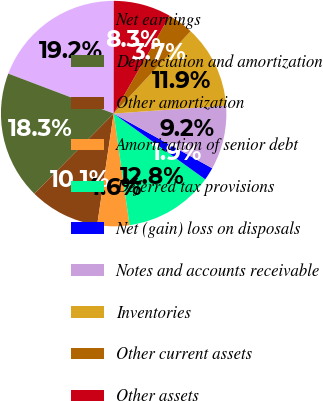Convert chart to OTSL. <chart><loc_0><loc_0><loc_500><loc_500><pie_chart><fcel>Net earnings<fcel>Depreciation and amortization<fcel>Other amortization<fcel>Amortization of senior debt<fcel>Deferred tax provisions<fcel>Net (gain) loss on disposals<fcel>Notes and accounts receivable<fcel>Inventories<fcel>Other current assets<fcel>Other assets<nl><fcel>19.25%<fcel>18.34%<fcel>10.09%<fcel>4.59%<fcel>12.84%<fcel>1.85%<fcel>9.18%<fcel>11.92%<fcel>3.68%<fcel>8.26%<nl></chart> 